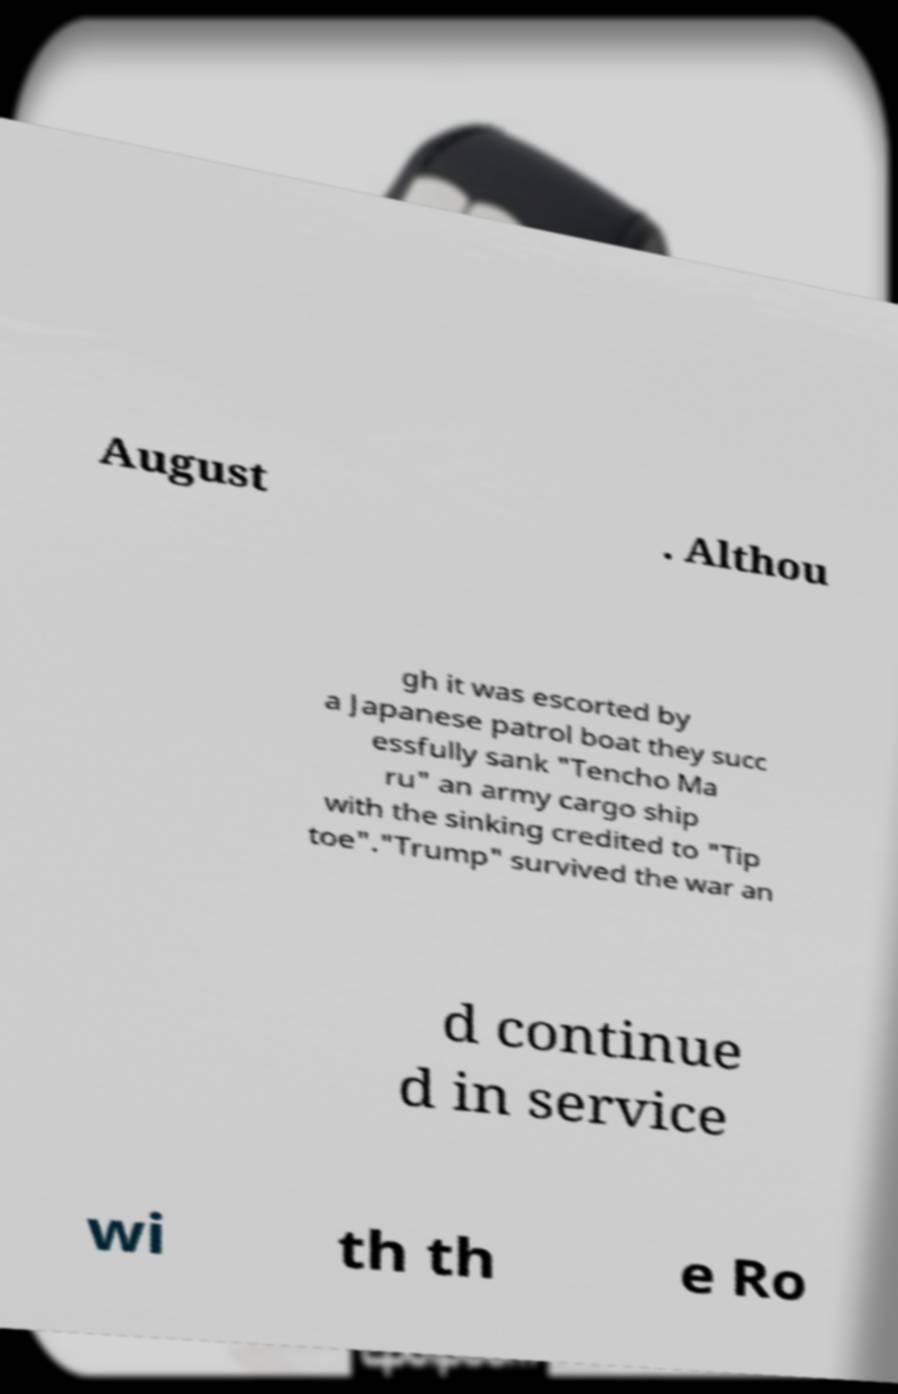Please read and relay the text visible in this image. What does it say? August . Althou gh it was escorted by a Japanese patrol boat they succ essfully sank "Tencho Ma ru" an army cargo ship with the sinking credited to "Tip toe"."Trump" survived the war an d continue d in service wi th th e Ro 